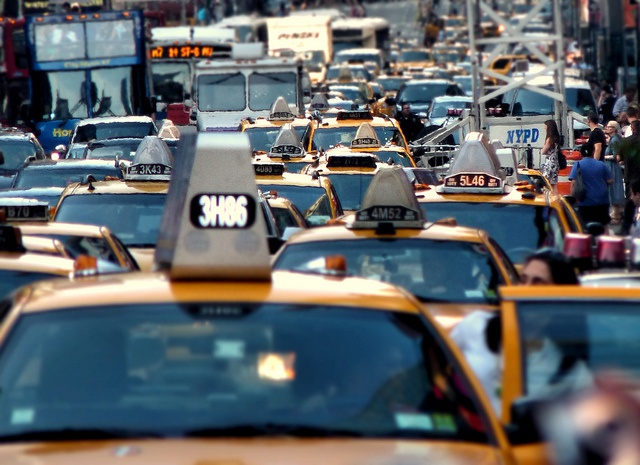Describe the objects in this image and their specific colors. I can see car in darkgreen, blue, black, darkblue, and darkgray tones, car in darkgreen, blue, gray, black, and navy tones, bus in darkgreen, darkgray, black, gray, and navy tones, car in darkgreen, blue, black, darkgray, and gray tones, and car in darkgreen, gray, blue, and darkgray tones in this image. 